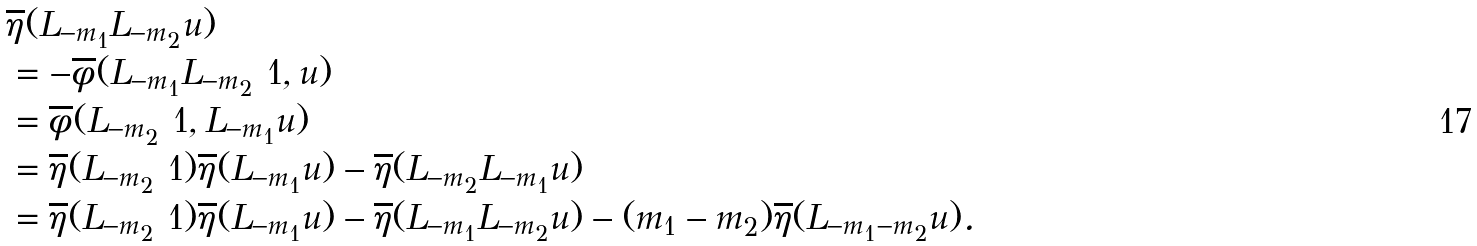Convert formula to latex. <formula><loc_0><loc_0><loc_500><loc_500>& \overline { \eta } ( L _ { - m _ { 1 } } L _ { - m _ { 2 } } u ) \\ & = - \overline { \phi } ( L _ { - m _ { 1 } } L _ { - m _ { 2 } } \ 1 , u ) \\ & = \overline { \phi } ( L _ { - m _ { 2 } } \ 1 , L _ { - m _ { 1 } } u ) \\ & = \overline { \eta } ( L _ { - m _ { 2 } } \ 1 ) \overline { \eta } ( L _ { - m _ { 1 } } u ) - \overline { \eta } ( L _ { - m _ { 2 } } L _ { - m _ { 1 } } u ) \\ & = \overline { \eta } ( L _ { - m _ { 2 } } \ 1 ) \overline { \eta } ( L _ { - m _ { 1 } } u ) - \overline { \eta } ( L _ { - m _ { 1 } } L _ { - m _ { 2 } } u ) - ( m _ { 1 } - m _ { 2 } ) \overline { \eta } ( L _ { - m _ { 1 } - m _ { 2 } } u ) .</formula> 